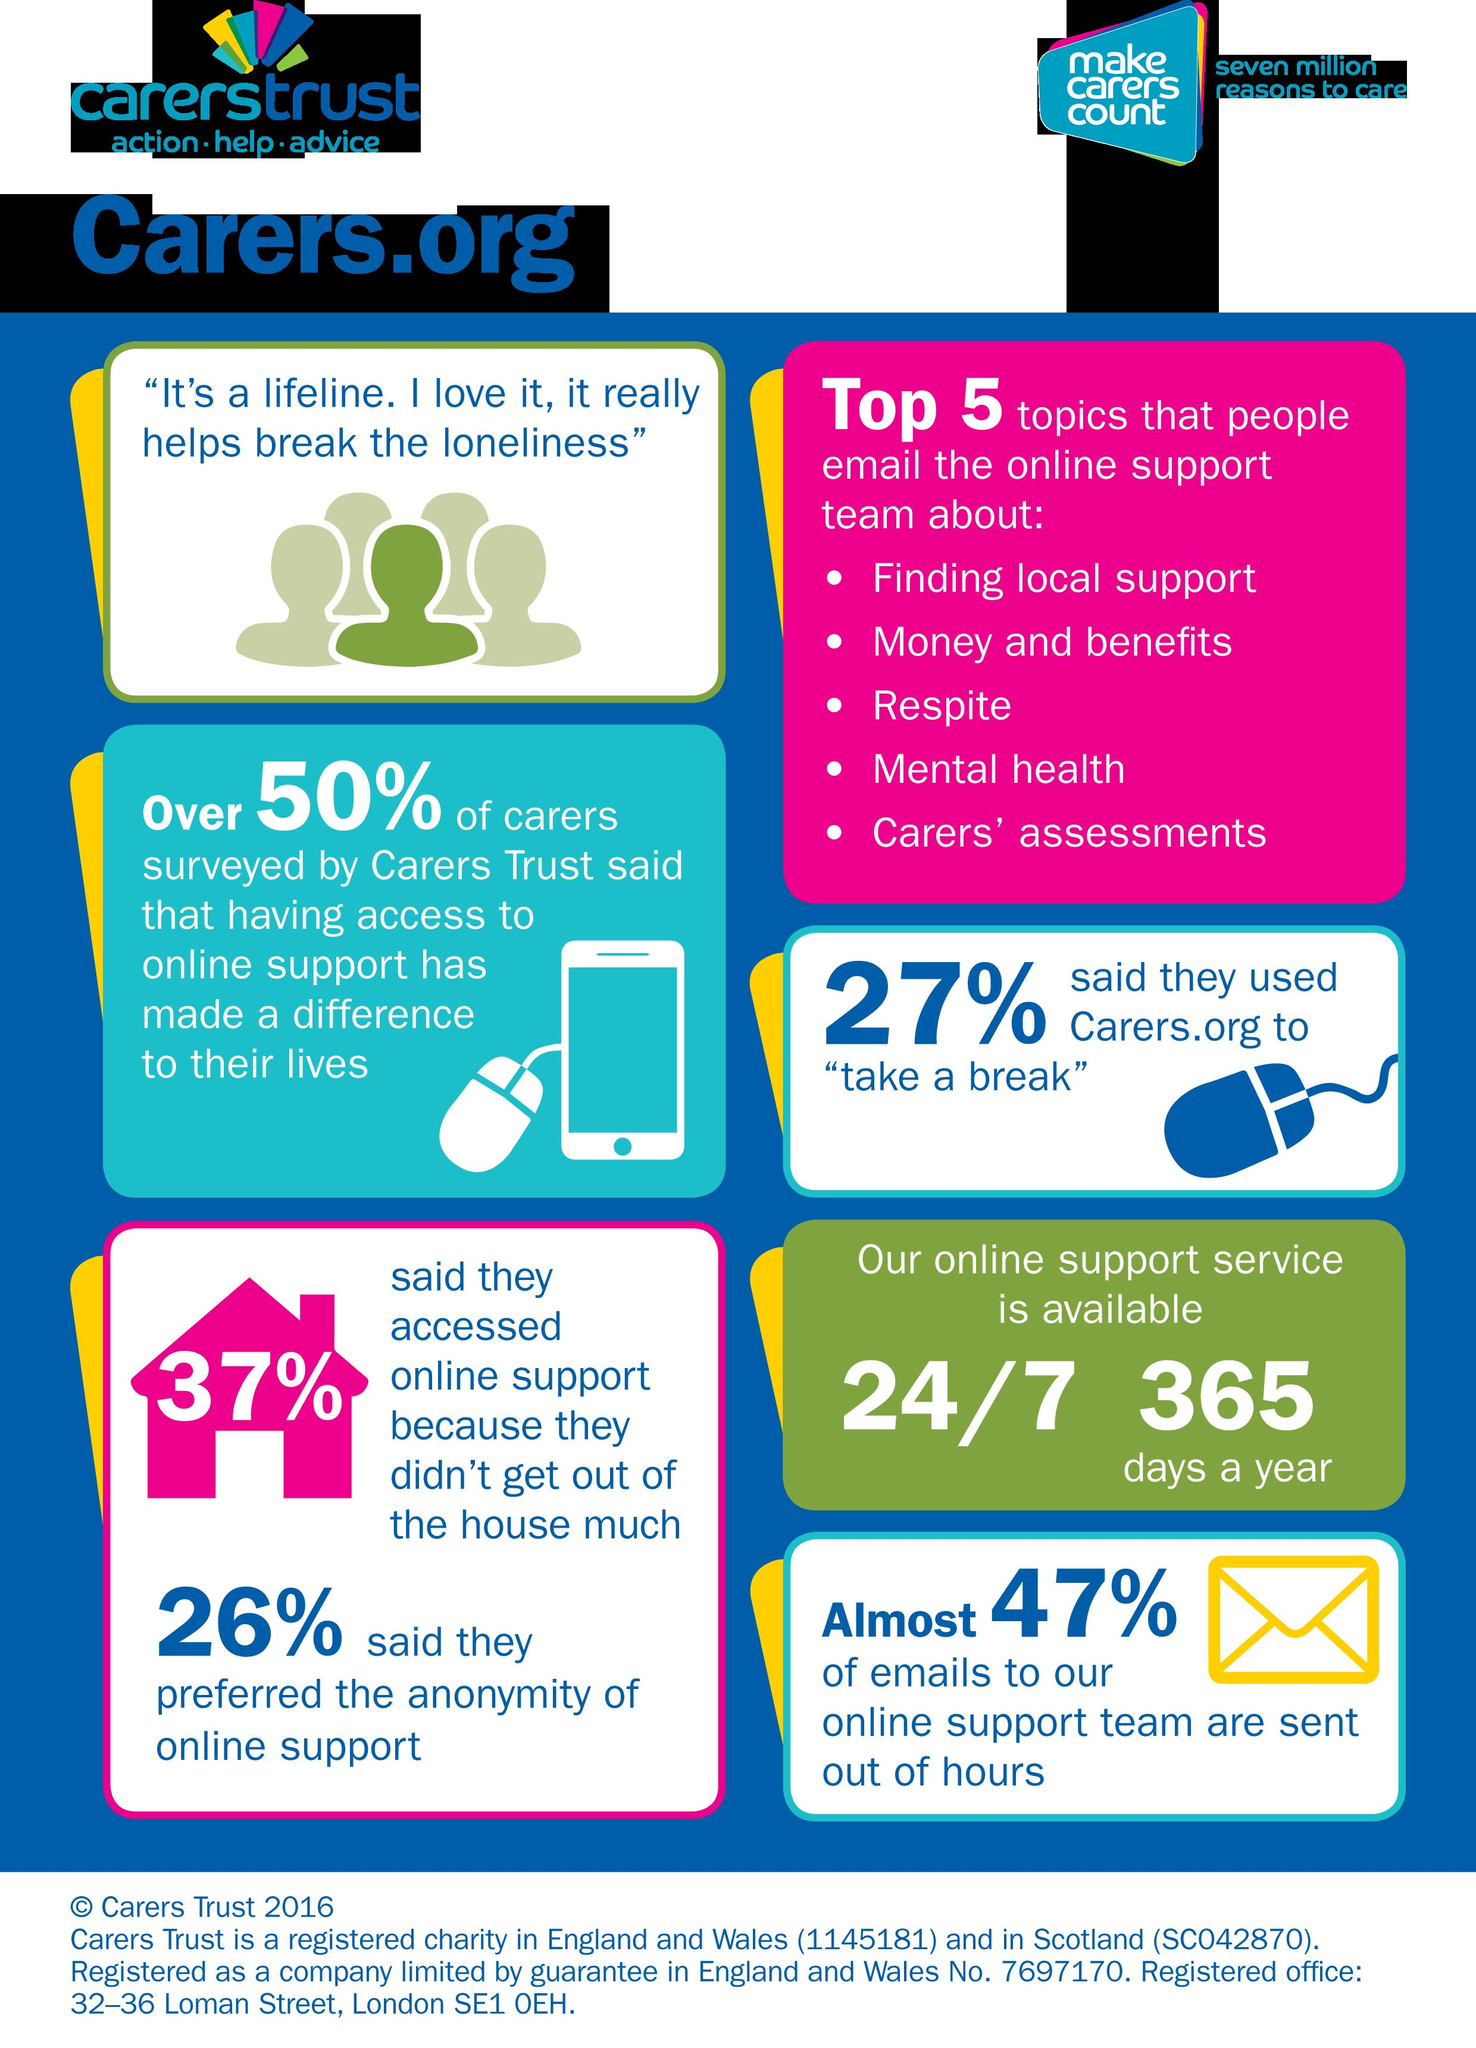Identify some key points in this picture. Carers.Org is available 24 hours a day, 7 days a week, 365 days a year for its working time. The Carers Online support team has received 53% of their emails during daytime hours. Approximately 73% of people have not yet contacted carers.org to take a break, indicating a significant portion of individuals who may benefit from these resources remain unreached. The fourth topic mentioned in the email to the online support team is mental health. The second topic mentioned in the email to the online support team is money and benefits. 